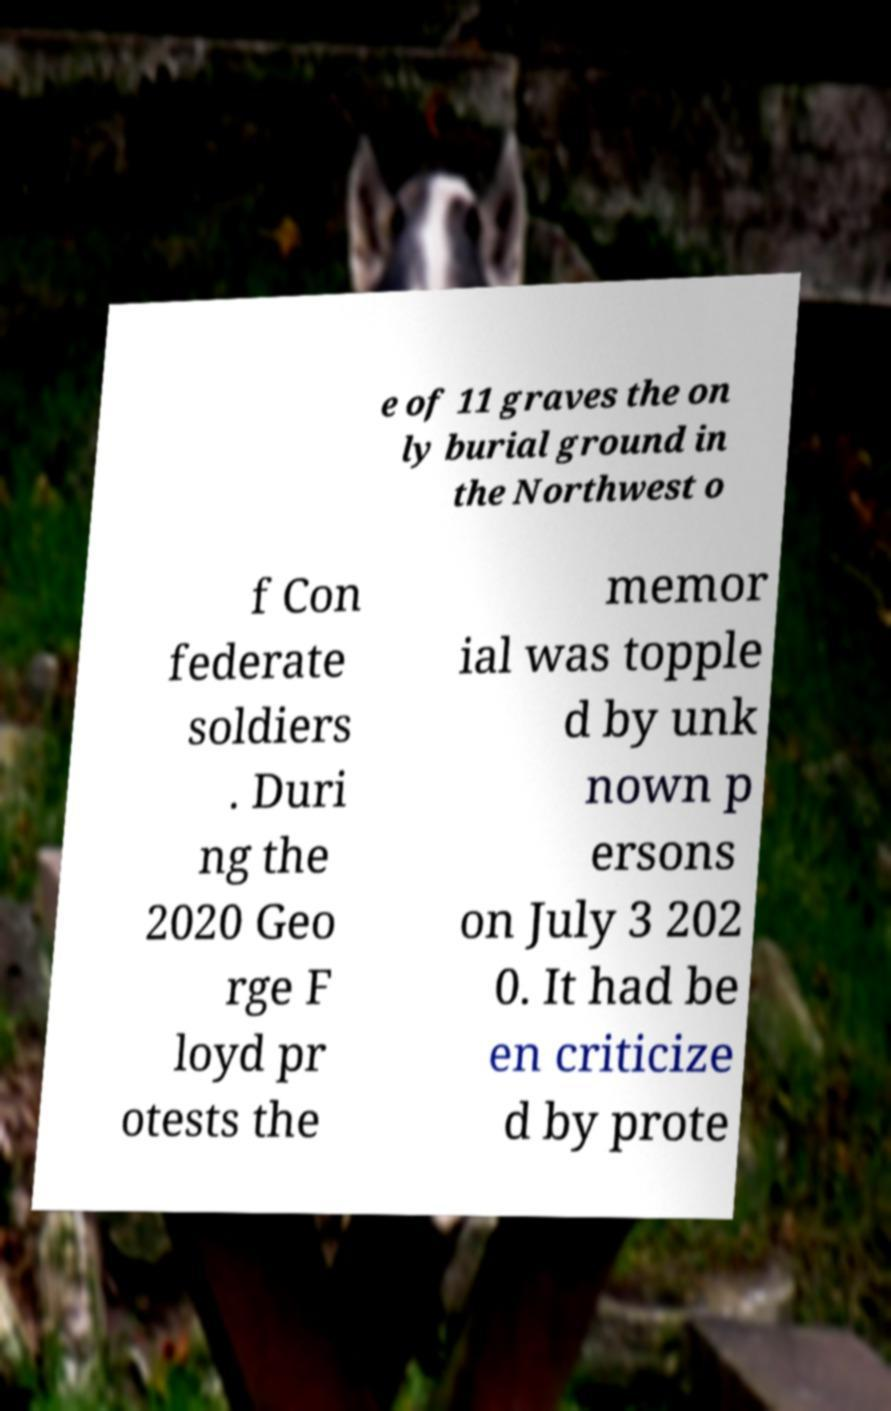For documentation purposes, I need the text within this image transcribed. Could you provide that? e of 11 graves the on ly burial ground in the Northwest o f Con federate soldiers . Duri ng the 2020 Geo rge F loyd pr otests the memor ial was topple d by unk nown p ersons on July 3 202 0. It had be en criticize d by prote 